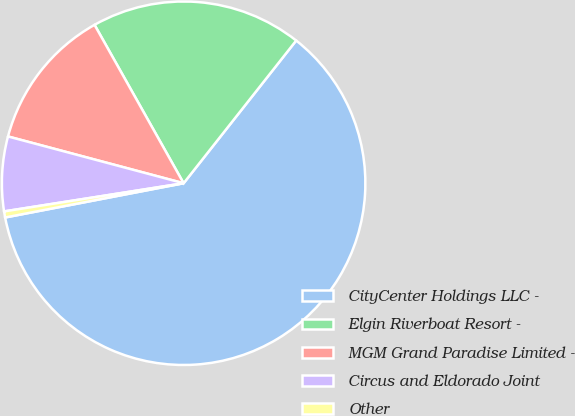<chart> <loc_0><loc_0><loc_500><loc_500><pie_chart><fcel>CityCenter Holdings LLC -<fcel>Elgin Riverboat Resort -<fcel>MGM Grand Paradise Limited -<fcel>Circus and Eldorado Joint<fcel>Other<nl><fcel>61.34%<fcel>18.78%<fcel>12.7%<fcel>6.62%<fcel>0.54%<nl></chart> 